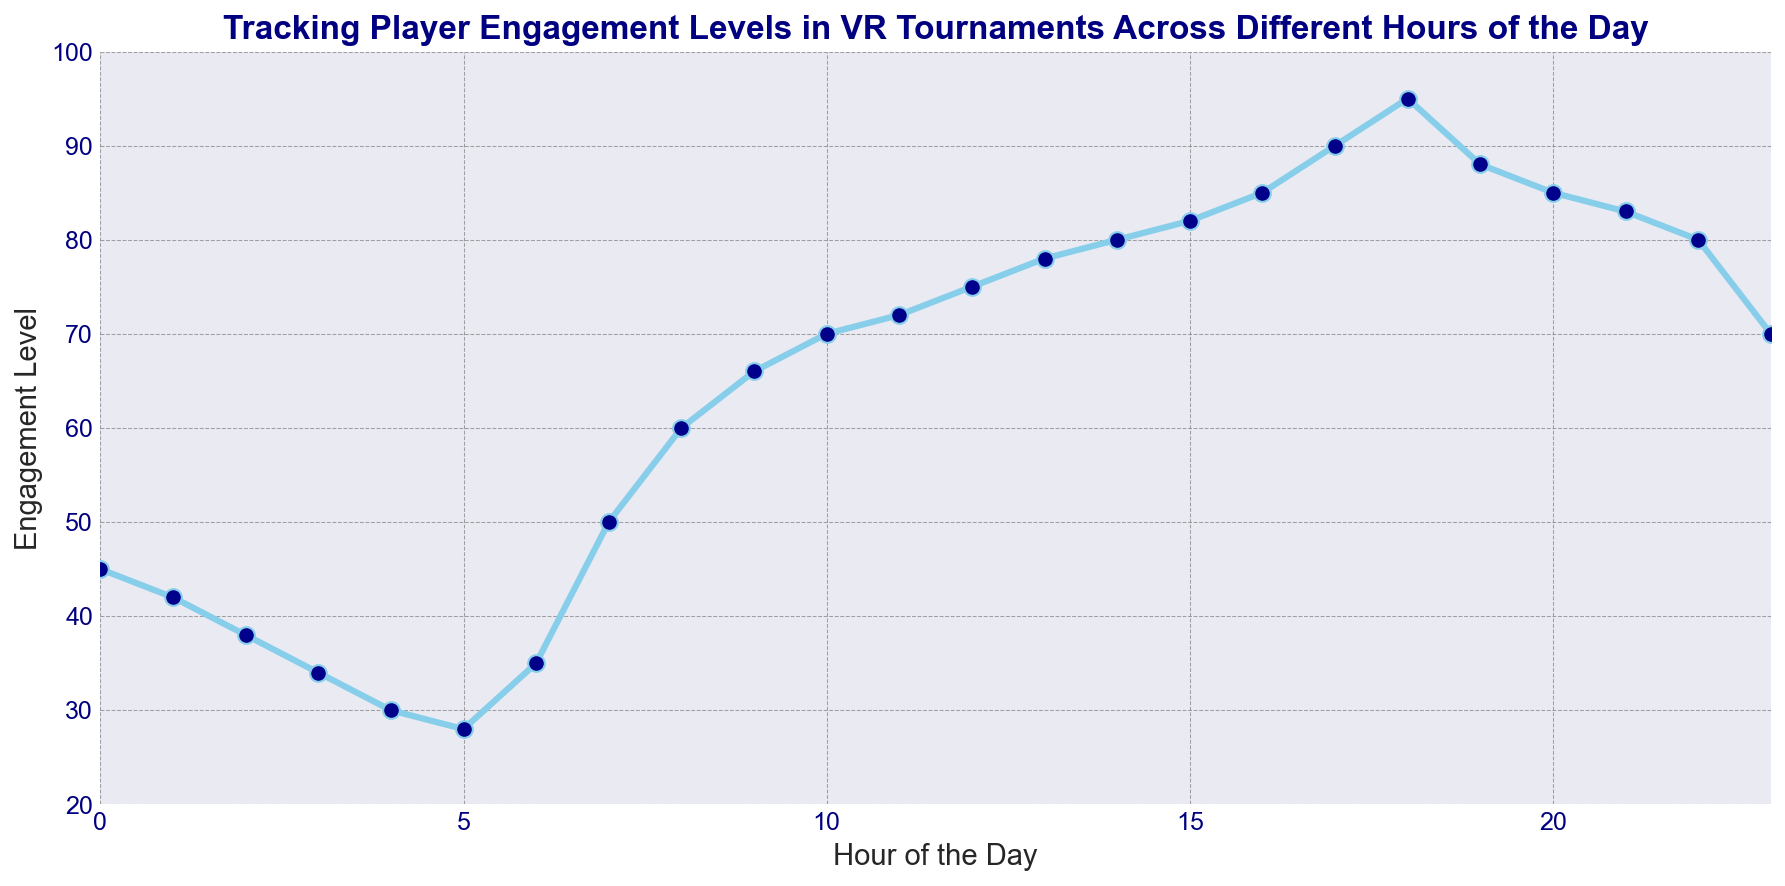What are the peak engagement hours? The peak engagement hours are when the engagement levels are highest on the line chart. The highest engagement level is 95, which occurs at 18 hours. The second highest peaks are at 17 hours and 19 hours with engagement levels of 90 and 88, respectively.
Answer: 17, 18, 19 What's the overall trend of player engagement throughout the day? To identify the overall trend, observe how the line moves from the beginning to the end. The engagement level starts relatively low, decreases until around 5 hours, rises steadily to its highest at around 18 hours, and then gradually decreases again towards the end of the day.
Answer: Rises and falls During which hours does engagement level increase significantly? Significant increases in engagement level appear as steep upward slopes in the graph. Steep slopes are observed between 6 hours and 11 hours and from 15 hours to 18 hours.
Answer: 6-11, 15-18 Does player engagement drop at any specific times? Drops in player engagement are shown by downward slopes in the graph. Significant drops occur between 0 and 5 hours, and between 18 and 23 hours.
Answer: 0-5, 18-23 How does player engagement from 6 to 7 hours compare to 22 to 23 hours? To compare engagement levels, observe the respective values at 6-7 hours and 22-23 hours. Engagement level increases from 35 to 50 between 6 and 7, while it decreases from 80 to 70 between 22 and 23 hours.
Answer: 6-7 increases, 22-23 decreases What is the average engagement level between 12 to 18 hours? Sum the engagement levels from 12 to 18 hours and divide by the number of hours (7). Calculations: (75+78+80+82+85+90+95)/7 = 85.
Answer: 85 At what hour does engagement level transition from decreasing to increasing first? The first clear transition from decreasing to increasing engagement level is determined by observing where the downward trend changes to an upward trend. This transition happens from 5 hours (28) to 6 hours (35).
Answer: 5-6 hours 